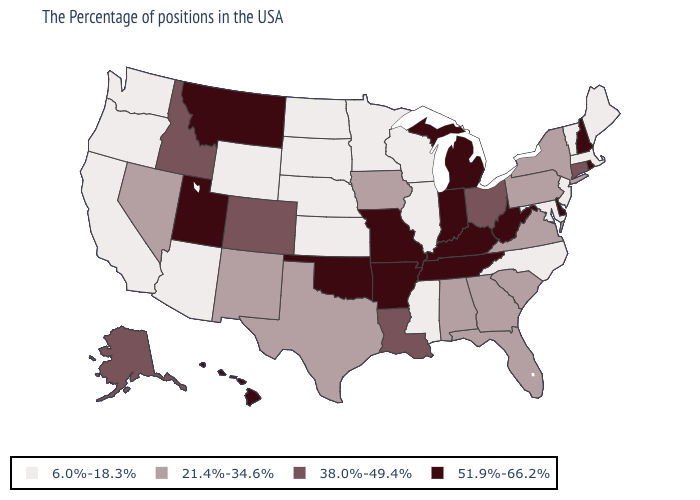Which states have the lowest value in the West?
Quick response, please. Wyoming, Arizona, California, Washington, Oregon. Among the states that border Colorado , which have the highest value?
Keep it brief. Oklahoma, Utah. Does the first symbol in the legend represent the smallest category?
Keep it brief. Yes. What is the value of New Jersey?
Answer briefly. 6.0%-18.3%. What is the lowest value in the South?
Be succinct. 6.0%-18.3%. Name the states that have a value in the range 21.4%-34.6%?
Be succinct. New York, Pennsylvania, Virginia, South Carolina, Florida, Georgia, Alabama, Iowa, Texas, New Mexico, Nevada. What is the value of Hawaii?
Concise answer only. 51.9%-66.2%. What is the value of Pennsylvania?
Give a very brief answer. 21.4%-34.6%. Which states have the lowest value in the USA?
Quick response, please. Maine, Massachusetts, Vermont, New Jersey, Maryland, North Carolina, Wisconsin, Illinois, Mississippi, Minnesota, Kansas, Nebraska, South Dakota, North Dakota, Wyoming, Arizona, California, Washington, Oregon. What is the value of Nebraska?
Quick response, please. 6.0%-18.3%. What is the value of Vermont?
Quick response, please. 6.0%-18.3%. Does the map have missing data?
Keep it brief. No. Does Connecticut have the highest value in the USA?
Quick response, please. No. Name the states that have a value in the range 51.9%-66.2%?
Keep it brief. Rhode Island, New Hampshire, Delaware, West Virginia, Michigan, Kentucky, Indiana, Tennessee, Missouri, Arkansas, Oklahoma, Utah, Montana, Hawaii. Is the legend a continuous bar?
Be succinct. No. 